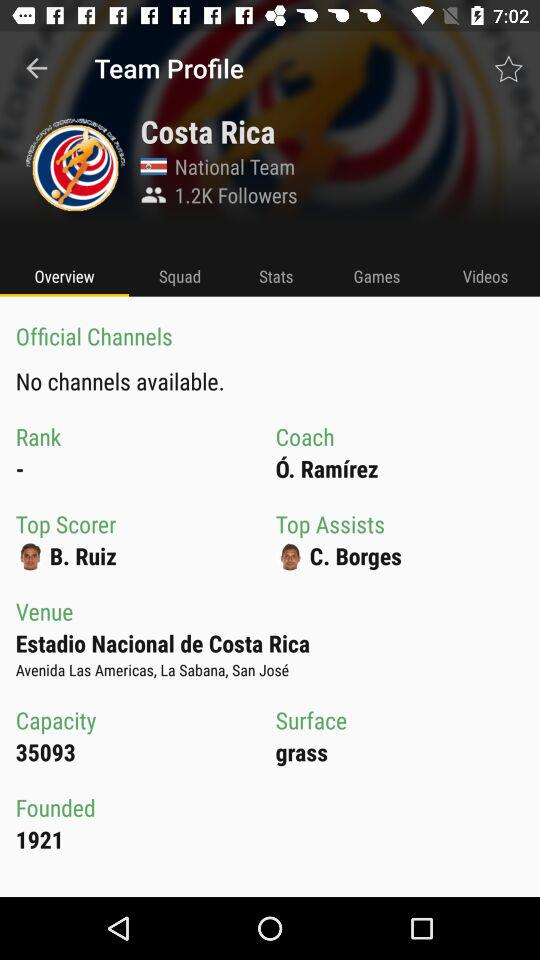How many followers does Costa Rica have? Costa Rica has 1.2K followers. 